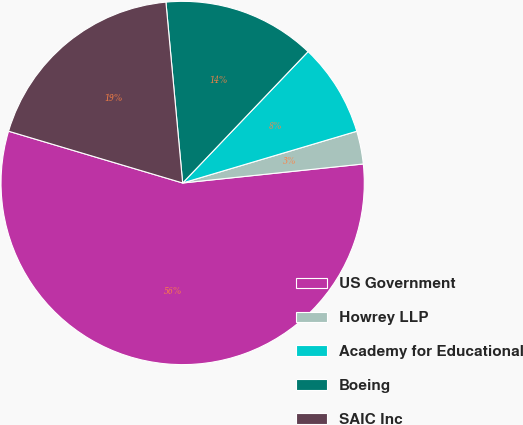Convert chart. <chart><loc_0><loc_0><loc_500><loc_500><pie_chart><fcel>US Government<fcel>Howrey LLP<fcel>Academy for Educational<fcel>Boeing<fcel>SAIC Inc<nl><fcel>56.27%<fcel>2.93%<fcel>8.27%<fcel>13.6%<fcel>18.93%<nl></chart> 